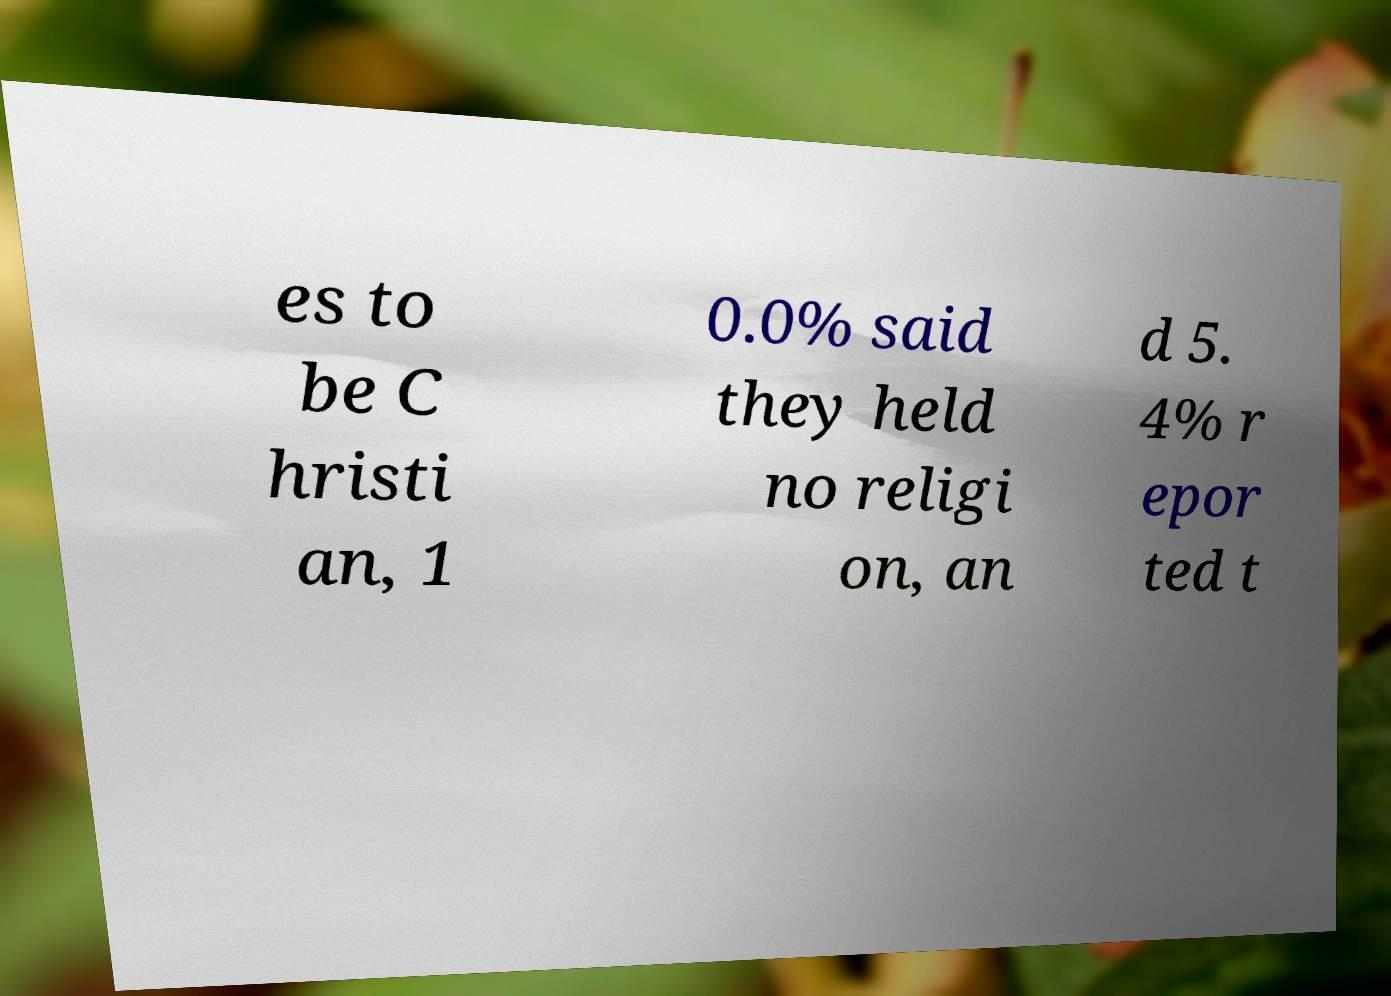There's text embedded in this image that I need extracted. Can you transcribe it verbatim? es to be C hristi an, 1 0.0% said they held no religi on, an d 5. 4% r epor ted t 